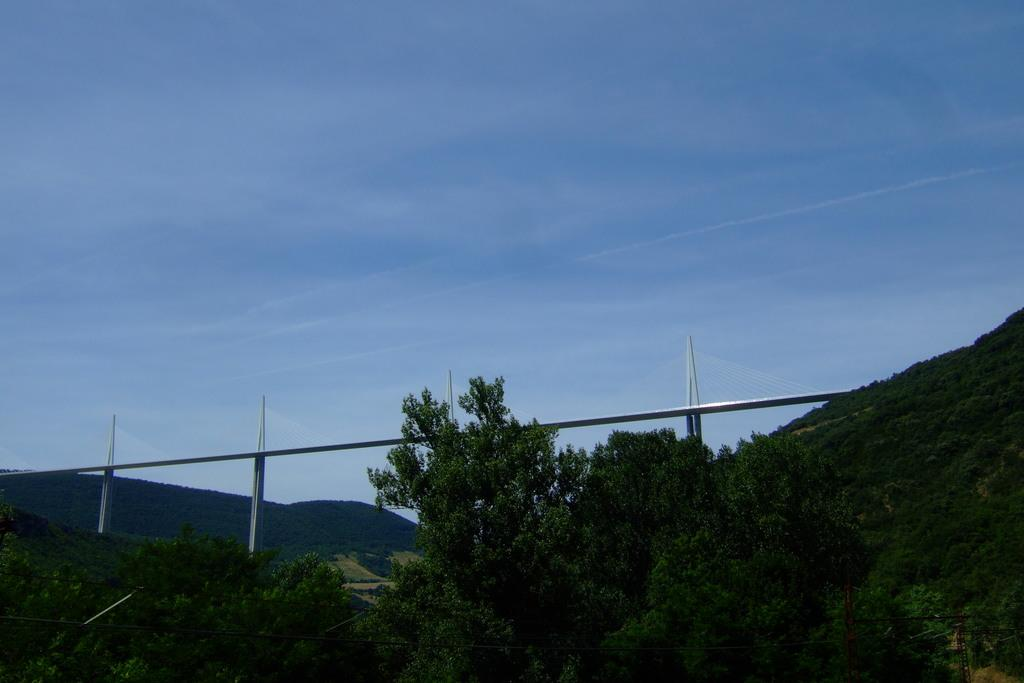What type of structure is present in the picture? There is a bridge in the picture. What specific feature can be observed on the bridge? The bridge has towers. What natural landscape is visible in the background of the picture? There are mountains in the picture. What is the vegetation like on the mountains? The mountains are covered with trees. How would you describe the weather based on the image? The sky is clear in the picture, suggesting good weather. How many cactus plants can be seen on the bridge in the image? There are no cactus plants present on the bridge or in the image. What type of art is displayed on the walls of the towers in the image? There is no art displayed on the walls of the towers in the image, as the focus is on the bridge and its towers. 